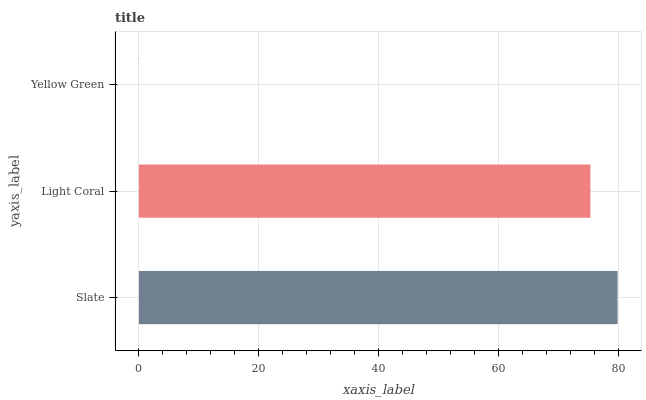Is Yellow Green the minimum?
Answer yes or no. Yes. Is Slate the maximum?
Answer yes or no. Yes. Is Light Coral the minimum?
Answer yes or no. No. Is Light Coral the maximum?
Answer yes or no. No. Is Slate greater than Light Coral?
Answer yes or no. Yes. Is Light Coral less than Slate?
Answer yes or no. Yes. Is Light Coral greater than Slate?
Answer yes or no. No. Is Slate less than Light Coral?
Answer yes or no. No. Is Light Coral the high median?
Answer yes or no. Yes. Is Light Coral the low median?
Answer yes or no. Yes. Is Slate the high median?
Answer yes or no. No. Is Slate the low median?
Answer yes or no. No. 